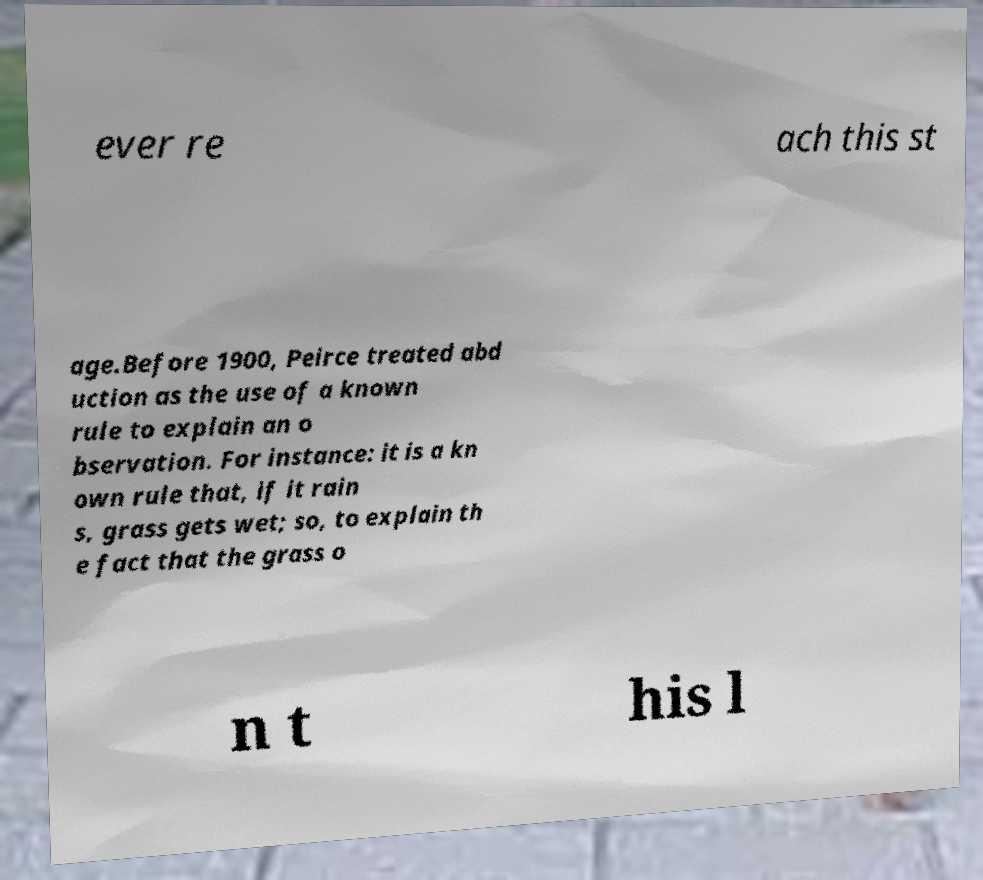For documentation purposes, I need the text within this image transcribed. Could you provide that? ever re ach this st age.Before 1900, Peirce treated abd uction as the use of a known rule to explain an o bservation. For instance: it is a kn own rule that, if it rain s, grass gets wet; so, to explain th e fact that the grass o n t his l 